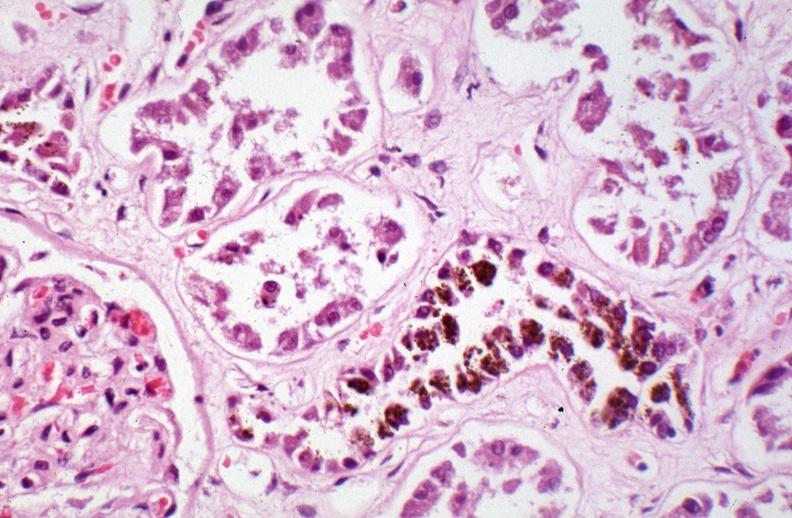does fibrinous peritonitis show kidney, chronic sickle cell disease?
Answer the question using a single word or phrase. No 